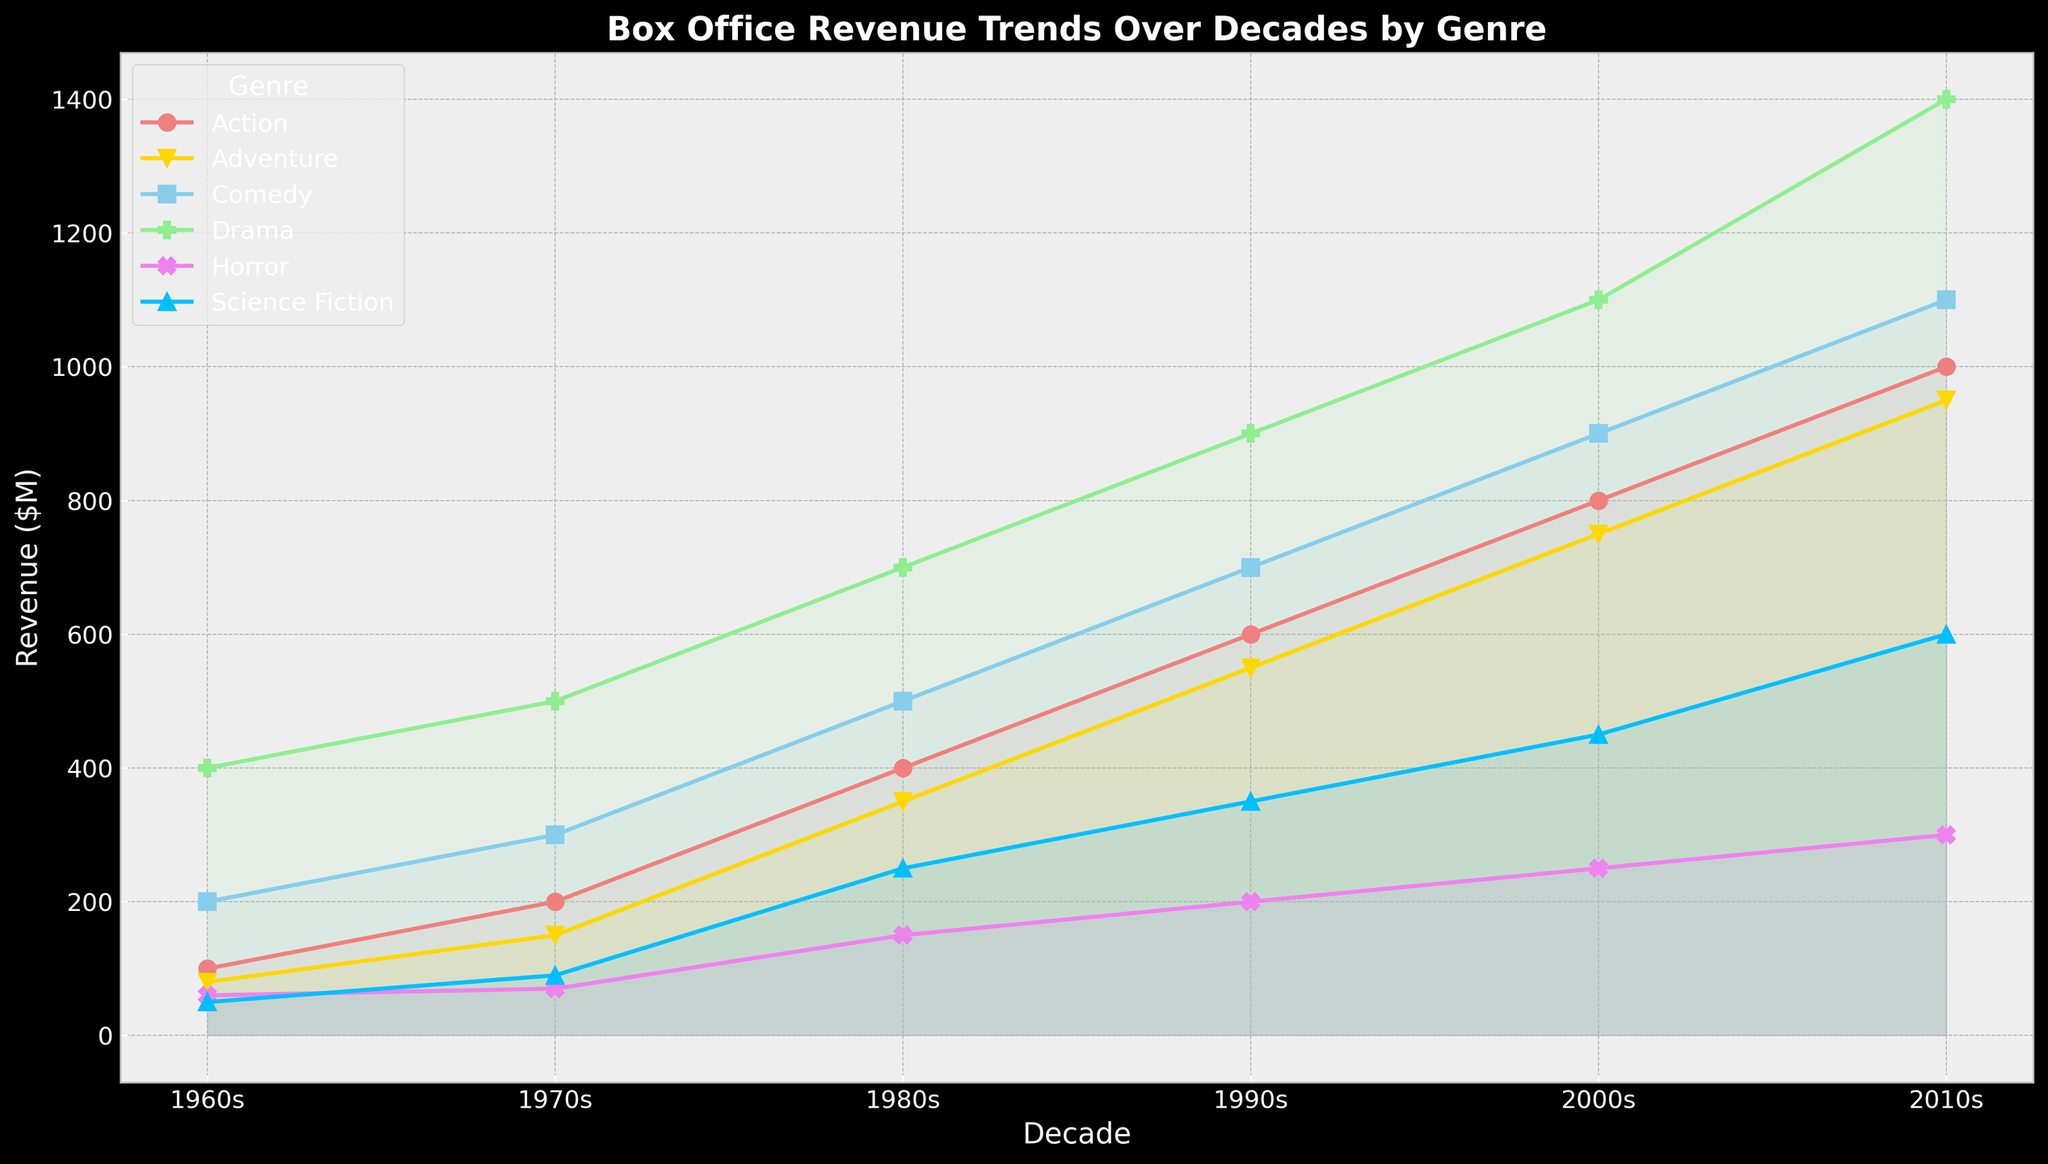Which genre showed the highest box office revenue in the 2010s? By referring to the plot, the highest point in the 2010s corresponds to the 'Drama' genre.
Answer: Drama In which decade did the 'Action' genre see the most significant increase in box office revenue compared to the previous decade? Comparing the heights of the 'Action' markers, the revenue increased by 200 between the 1970s and 1980s (from 200 to 400) and the 1980s and 1990s (from 400 to 600), both being the highest jumps.
Answer: 1980s and 1990s How did the sum of box office revenues for 'Horror' and 'Science Fiction' change from the 1960s to the 2010s? In the 1960s, 'Horror' was 60, and 'Science Fiction' was 50, summing to 110. In the 2010s, 'Horror' was 300, and 'Science Fiction' was 600, summing to 900. Hence, the change is 900 - 110 = 790.
Answer: Increased by 790 Between the 1980s and the 2010s, which genre experienced a greater absolute increase in box office revenue: 'Comedy' or 'Adventure'? 'Comedy' increased from 500 to 1100 (600 increase) and 'Adventure' from 350 to 950 (600 increase), so both genres experienced the same increase.
Answer: Both the same What is the average box office revenue for the 'Drama' genre across all decades? Sum the revenues of 'Drama' across all decades (400 + 500 + 700 + 900 + 1100 + 1400 = 5000) and divide by the number of decades (6): 5000 / 6 ≈ 833.33.
Answer: ~833.33 Which genre had the least box office revenue consistently throughout the decades? By comparing the heights of all genre markers across all decades, 'Science Fiction' consistently had the lowest revenues.
Answer: Science Fiction Did 'Comedy' or 'Horror' have a higher box office revenue in the 1990s, and by how much? In the 1990s, 'Comedy' had 700 and 'Horror' had 200. Subtract 'Horror' from 'Comedy': 700 - 200 = 500.
Answer: Comedy by 500 What is the total box office revenue for 'Action' from the 1960s to the 2010s? Sum the box office revenues for 'Action': 100 + 200 + 400 + 600 + 800 + 1000 = 3100.
Answer: 3100 Which decade saw the largest relative increase in 'Drama' compared to the previous decade? Calculate the relative increases: (500-400)/400 = 0.25, (700-500)/500 = 0.4, (900-700)/700 ≈ 0.2857, (1100-900)/900 ≈ 0.2222, (1400-1100)/1100 ≈ 0.2727. The largest is 0.4 (40%) from the 1980s to 1990s.
Answer: From the 1980s to the 1990s Which genres show their revenue crossing over each other from the 1980s to the 2010s? The lines for 'Adventure' and 'Comedy' cross between the 1980s and the 2010s. Inspect the lines connecting these points.
Answer: Adventure and Comedy 